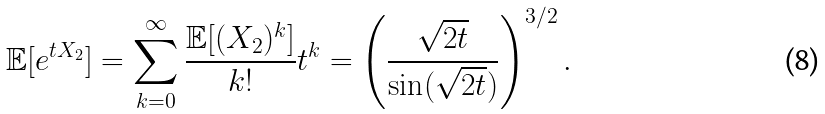<formula> <loc_0><loc_0><loc_500><loc_500>\mathbb { E } [ e ^ { t X _ { 2 } } ] = \sum _ { k = 0 } ^ { \infty } \frac { \mathbb { E } [ ( X _ { 2 } ) ^ { k } ] } { k ! } t ^ { k } = \left ( \frac { \sqrt { 2 t } } { \sin ( \sqrt { 2 t } ) } \right ) ^ { 3 / 2 } .</formula> 